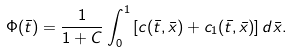<formula> <loc_0><loc_0><loc_500><loc_500>\Phi ( \bar { t } ) = \frac { 1 } { 1 + C } \int _ { 0 } ^ { 1 } \left [ c ( \bar { t } , \bar { x } ) + c _ { 1 } ( \bar { t } , \bar { x } ) \right ] d \bar { x } .</formula> 